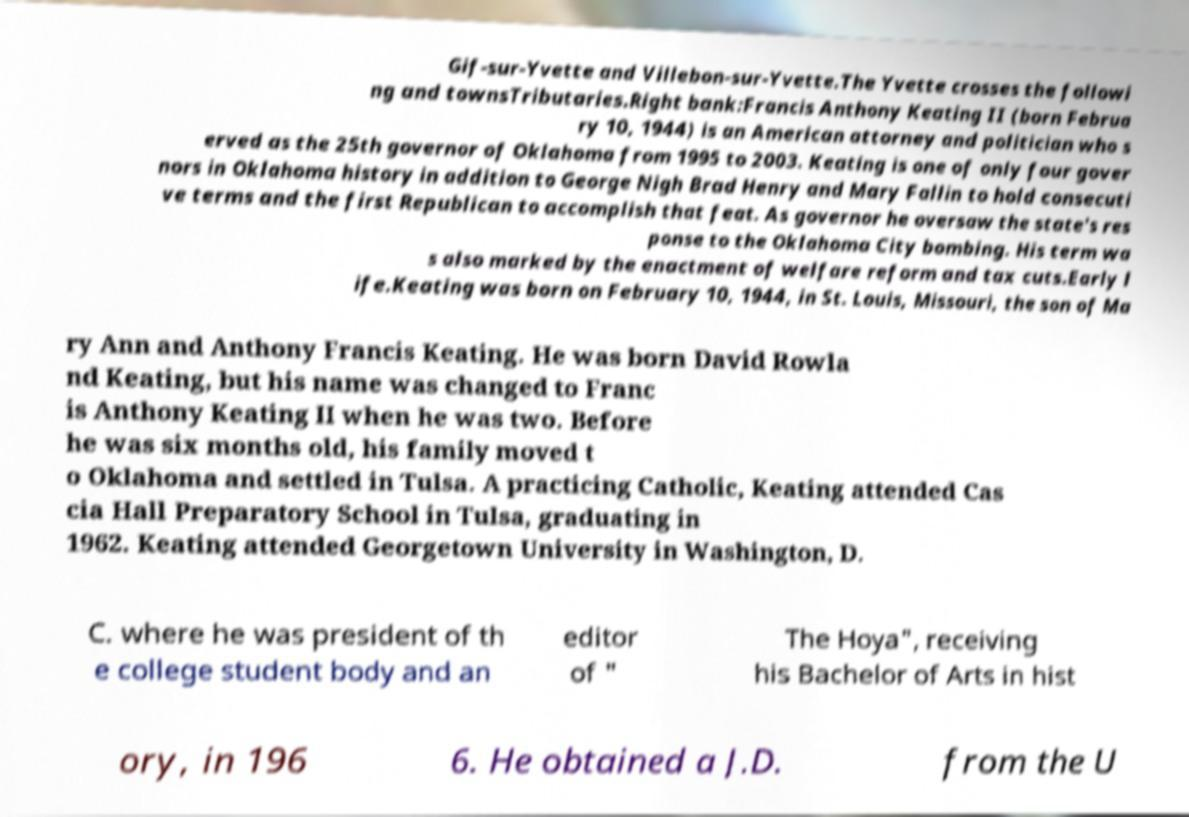For documentation purposes, I need the text within this image transcribed. Could you provide that? Gif-sur-Yvette and Villebon-sur-Yvette.The Yvette crosses the followi ng and townsTributaries.Right bank:Francis Anthony Keating II (born Februa ry 10, 1944) is an American attorney and politician who s erved as the 25th governor of Oklahoma from 1995 to 2003. Keating is one of only four gover nors in Oklahoma history in addition to George Nigh Brad Henry and Mary Fallin to hold consecuti ve terms and the first Republican to accomplish that feat. As governor he oversaw the state's res ponse to the Oklahoma City bombing. His term wa s also marked by the enactment of welfare reform and tax cuts.Early l ife.Keating was born on February 10, 1944, in St. Louis, Missouri, the son of Ma ry Ann and Anthony Francis Keating. He was born David Rowla nd Keating, but his name was changed to Franc is Anthony Keating II when he was two. Before he was six months old, his family moved t o Oklahoma and settled in Tulsa. A practicing Catholic, Keating attended Cas cia Hall Preparatory School in Tulsa, graduating in 1962. Keating attended Georgetown University in Washington, D. C. where he was president of th e college student body and an editor of " The Hoya", receiving his Bachelor of Arts in hist ory, in 196 6. He obtained a J.D. from the U 